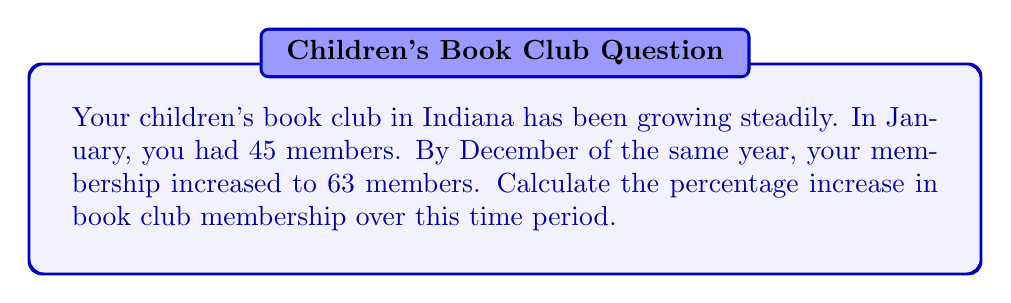Help me with this question. To calculate the percentage increase in book club membership, we need to follow these steps:

1. Calculate the absolute increase in membership:
   $\text{Increase} = \text{Final value} - \text{Initial value}$
   $\text{Increase} = 63 - 45 = 18$ members

2. Calculate the percentage increase using the formula:
   $$\text{Percentage increase} = \frac{\text{Increase}}{\text{Initial value}} \times 100\%$$

3. Substitute the values into the formula:
   $$\text{Percentage increase} = \frac{18}{45} \times 100\%$$

4. Simplify the fraction:
   $$\text{Percentage increase} = \frac{2}{5} \times 100\%$$

5. Perform the multiplication:
   $$\text{Percentage increase} = 0.4 \times 100\% = 40\%$$

Therefore, the percentage increase in book club membership over the year is 40%.
Answer: 40% 